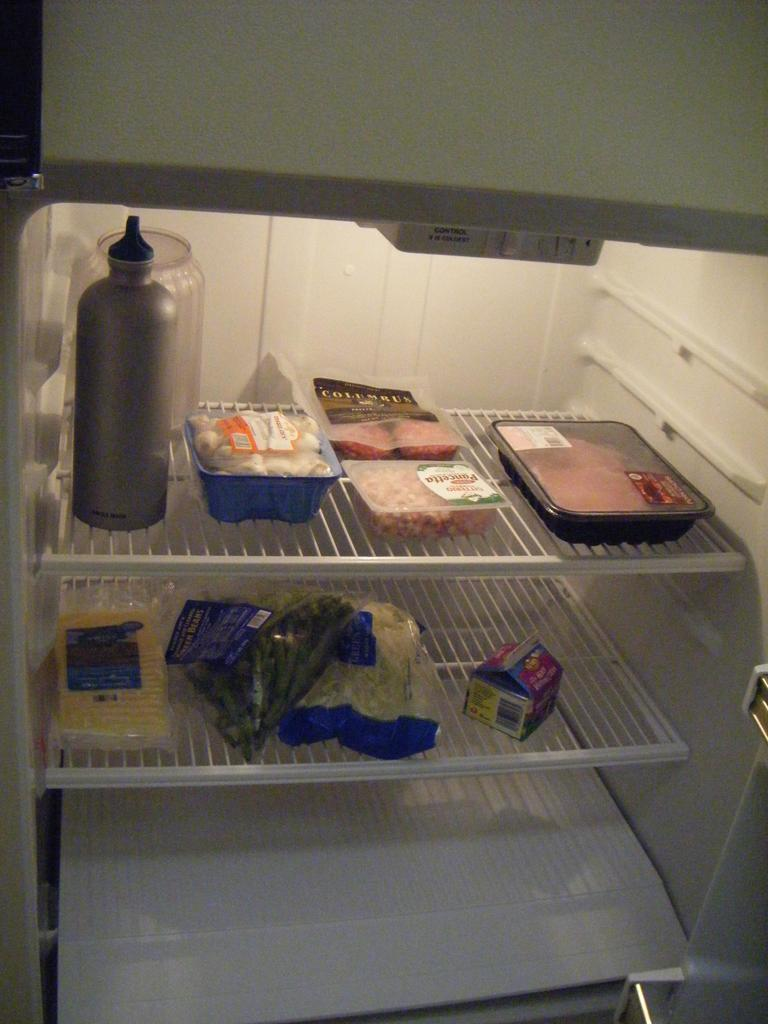Where was the image taken? The image is taken inside a fridge. How many trays are visible in the image? There are two trays in the image. What types of items are on the trays? There are meat boxes, a bottle, peas, and boxes on the trays. What type of cup is being used to hold the peas in the image? There is no cup present in the image; the peas are directly on the tray. 